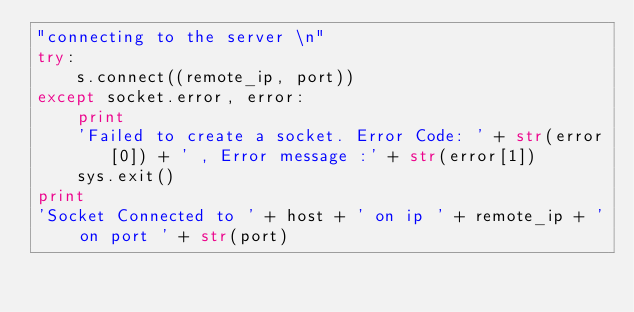Convert code to text. <code><loc_0><loc_0><loc_500><loc_500><_Python_>"connecting to the server \n"
try:
    s.connect((remote_ip, port))
except socket.error, error:
    print
    'Failed to create a socket. Error Code: ' + str(error[0]) + ' , Error message :' + str(error[1])
    sys.exit()
print
'Socket Connected to ' + host + ' on ip ' + remote_ip + ' on port ' + str(port)
</code> 